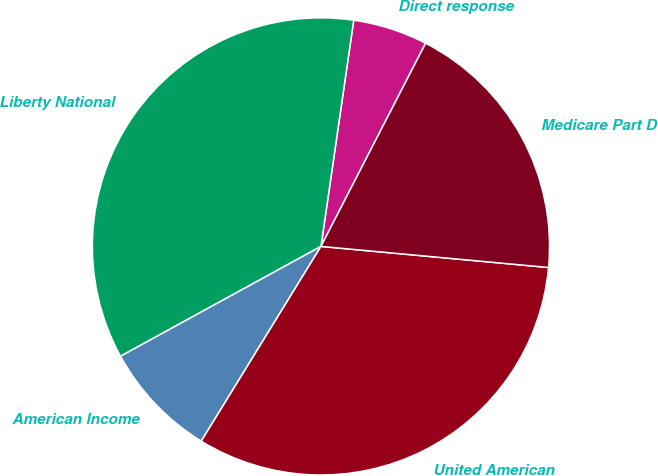Convert chart to OTSL. <chart><loc_0><loc_0><loc_500><loc_500><pie_chart><fcel>Direct response<fcel>Liberty National<fcel>American Income<fcel>United American<fcel>Medicare Part D<nl><fcel>5.28%<fcel>35.27%<fcel>8.25%<fcel>32.3%<fcel>18.9%<nl></chart> 